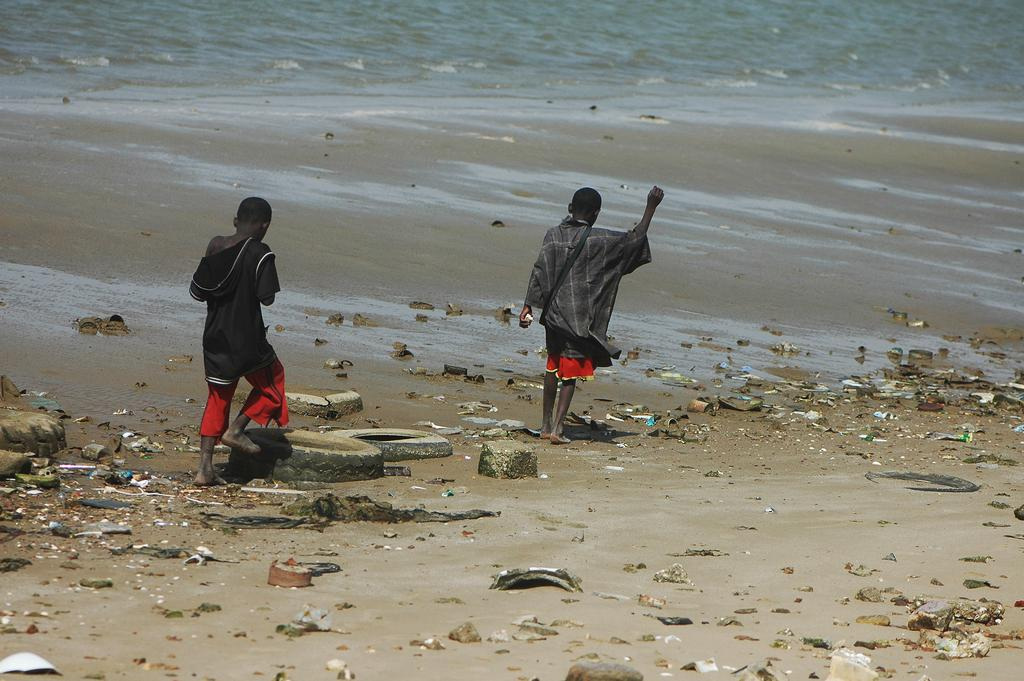What type of location is depicted in the image? There is a beach in the image. What is a characteristic feature of the beach? The beach has sand. What can be seen floating in the air in the image? Dust particles are visible in the image. What type of vegetation is present at the beach? There are trees in the image. What are the two children in the image doing? Two children are walking in the image. What can be seen in the distance behind the beach? There is water visible in the background of the image. What type of stretch can be seen on the beach in the image? There is no stretch visible on the beach in the image. What type of zipper can be seen on the children's clothing in the image? There is no zipper visible on the children's clothing in the image. 